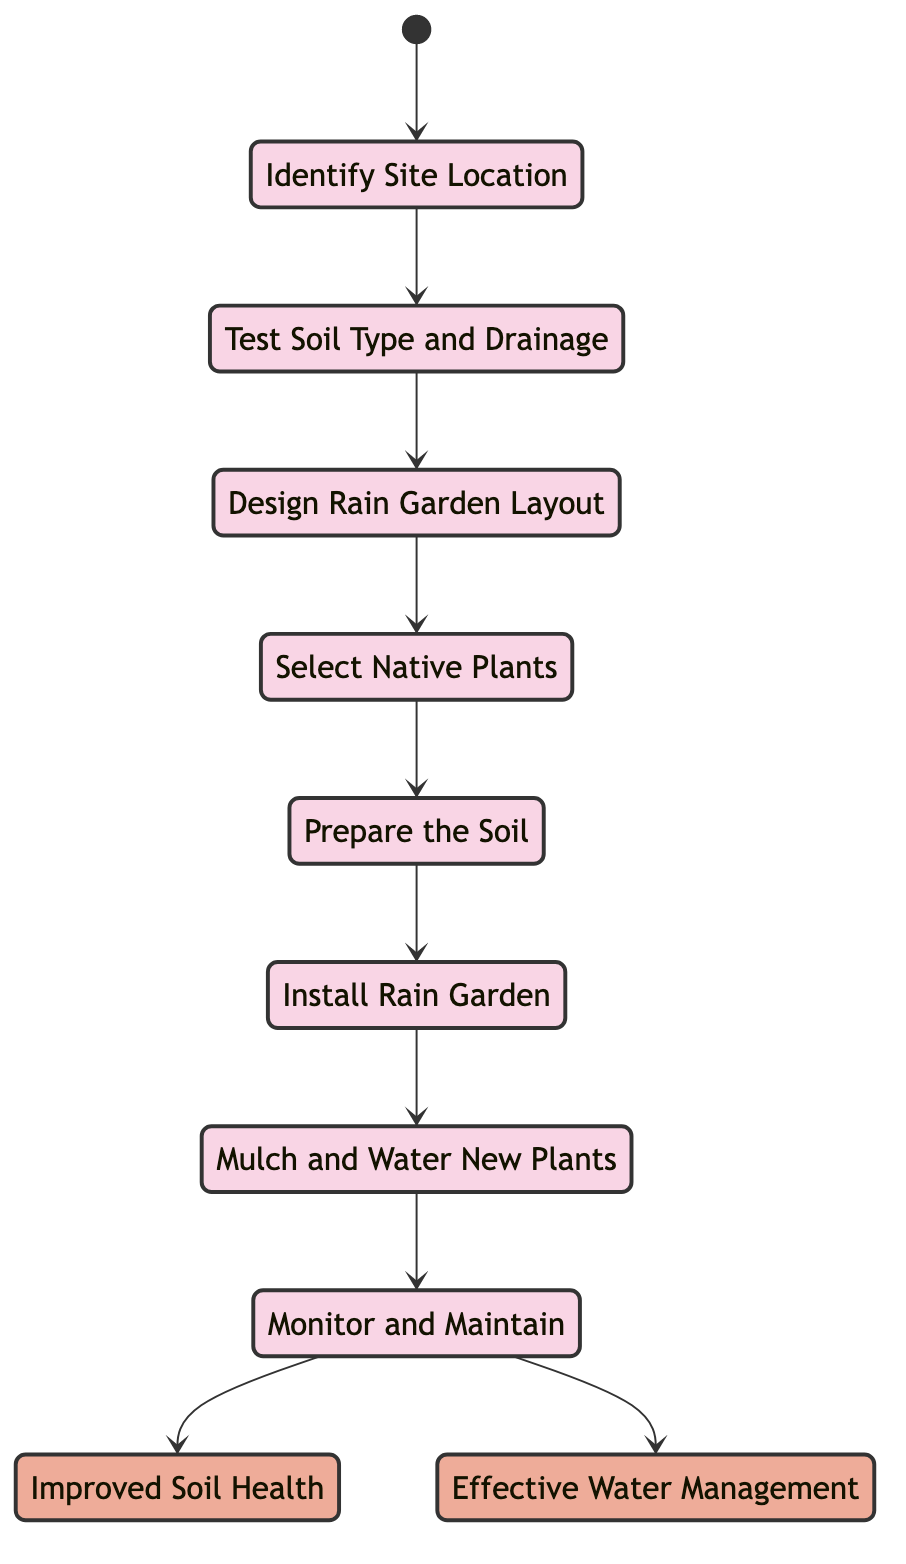What is the first action in the diagram? The diagram begins with the action "Identify Site Location," which is the initial step before other actions can take place.
Answer: Identify Site Location How many actions are in the diagram? The diagram lists a total of 8 actions. This includes actions from identifying the site to monitoring and maintaining the garden.
Answer: 8 What is the last outcome indicated in the diagram? The last outcome that the diagram leads to is "Effective Water Management," which is achieved through the various actions performed in building the rain garden.
Answer: Effective Water Management Which action directly follows the "Prepare the Soil"? The action that follows "Prepare the Soil" is "Install Rain Garden." This reflects the sequential progression towards the installation after preparing the soil.
Answer: Install Rain Garden What outcomes are achieved after "Monitor and Maintain"? After "Monitor and Maintain," the outcomes achieved are "Improved Soil Health" and "Effective Water Management," showing that proper maintenance leads to both benefits.
Answer: Improved Soil Health, Effective Water Management Which action involves selecting plants? The action that involves selecting plants is "Select Native Plants." This step focuses on choosing appropriate plant species for the rain garden.
Answer: Select Native Plants What is required to ensure the rain garden remains functional? Regularly checking plant health, soil moisture, and weed growth is required to ensure that the rain garden remains functional, as indicated in the "Monitor and Maintain" action.
Answer: Monitor and Maintain What comes after "Design Rain Garden Layout"? The action that comes after "Design Rain Garden Layout" is "Select Native Plants," which indicates the sequence of planning followed by plant selection.
Answer: Select Native Plants 